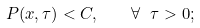<formula> <loc_0><loc_0><loc_500><loc_500>P ( x , \tau ) < C , \quad \forall \ \tau > 0 ;</formula> 